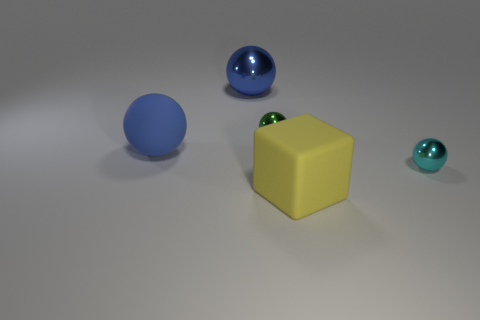How many other objects are the same material as the small green thing?
Offer a terse response. 2. How many cyan things are either small shiny balls or spheres?
Provide a succinct answer. 1. There is a blue object to the right of the blue rubber ball; is its shape the same as the matte thing that is behind the yellow matte block?
Offer a very short reply. Yes. Do the big matte ball and the small metallic thing that is on the right side of the big block have the same color?
Your answer should be very brief. No. Do the large rubber object that is right of the blue rubber ball and the big shiny thing have the same color?
Offer a terse response. No. What number of objects are either big blue matte objects or objects that are right of the blue matte sphere?
Your answer should be very brief. 5. The big object that is behind the small cyan shiny thing and in front of the big metal object is made of what material?
Ensure brevity in your answer.  Rubber. What is the material of the large yellow thing that is on the left side of the tiny cyan ball?
Your answer should be very brief. Rubber. What color is the other object that is the same material as the big yellow object?
Offer a terse response. Blue. There is a tiny green shiny thing; is it the same shape as the big rubber object behind the small cyan shiny object?
Ensure brevity in your answer.  Yes. 